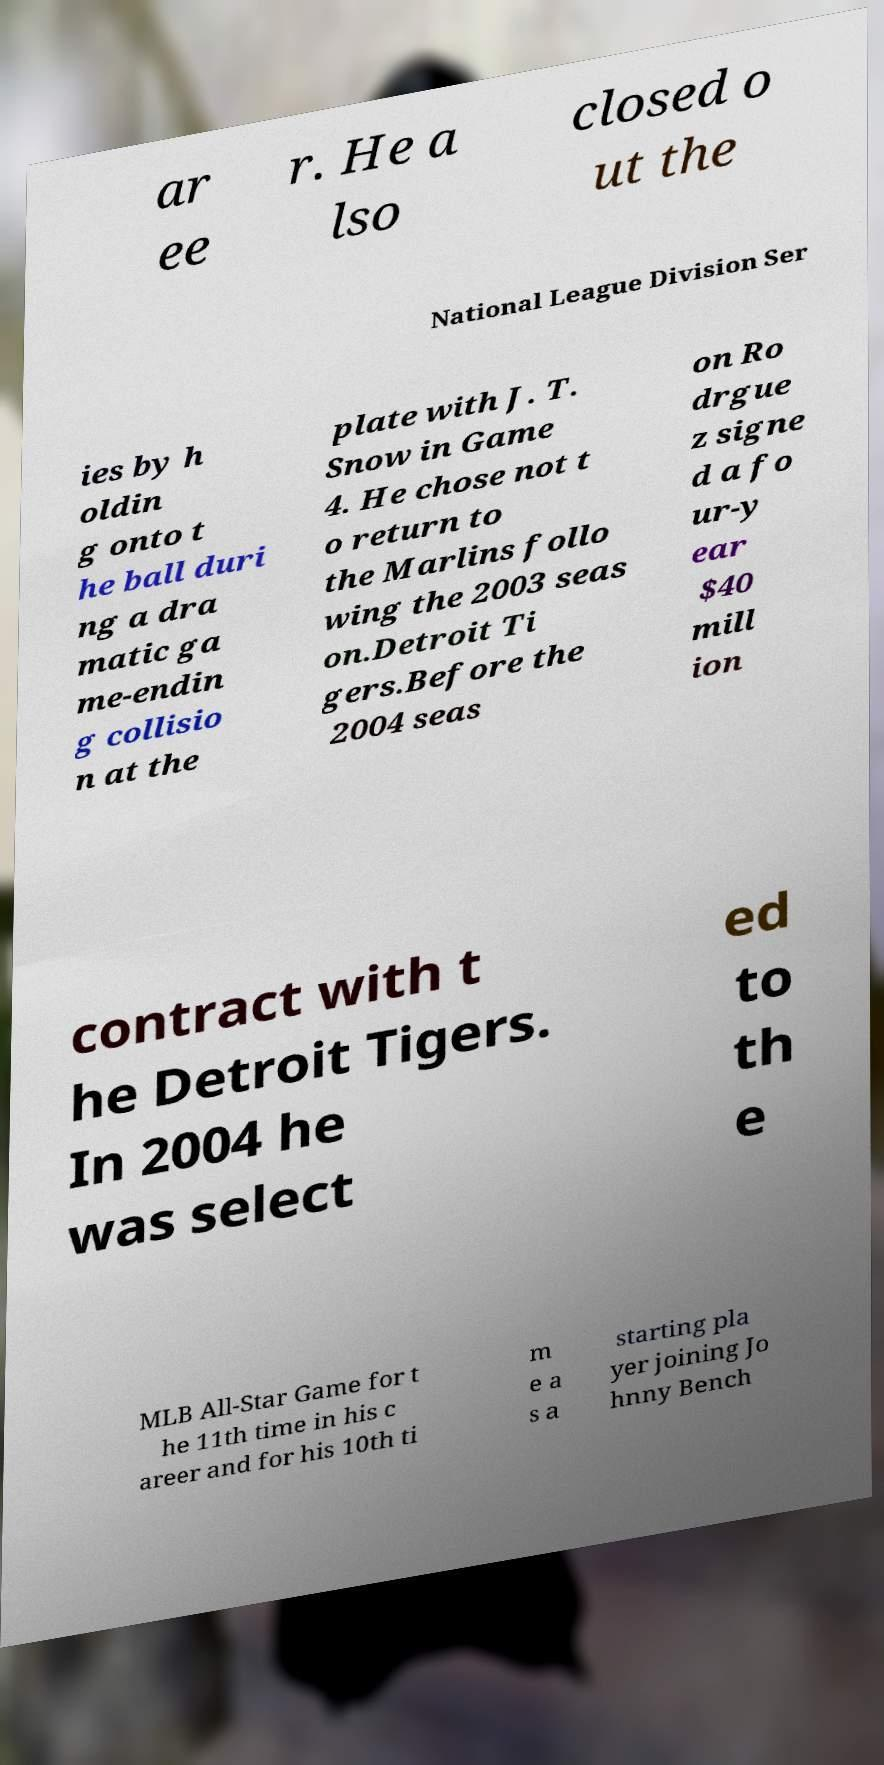Can you accurately transcribe the text from the provided image for me? ar ee r. He a lso closed o ut the National League Division Ser ies by h oldin g onto t he ball duri ng a dra matic ga me-endin g collisio n at the plate with J. T. Snow in Game 4. He chose not t o return to the Marlins follo wing the 2003 seas on.Detroit Ti gers.Before the 2004 seas on Ro drgue z signe d a fo ur-y ear $40 mill ion contract with t he Detroit Tigers. In 2004 he was select ed to th e MLB All-Star Game for t he 11th time in his c areer and for his 10th ti m e a s a starting pla yer joining Jo hnny Bench 